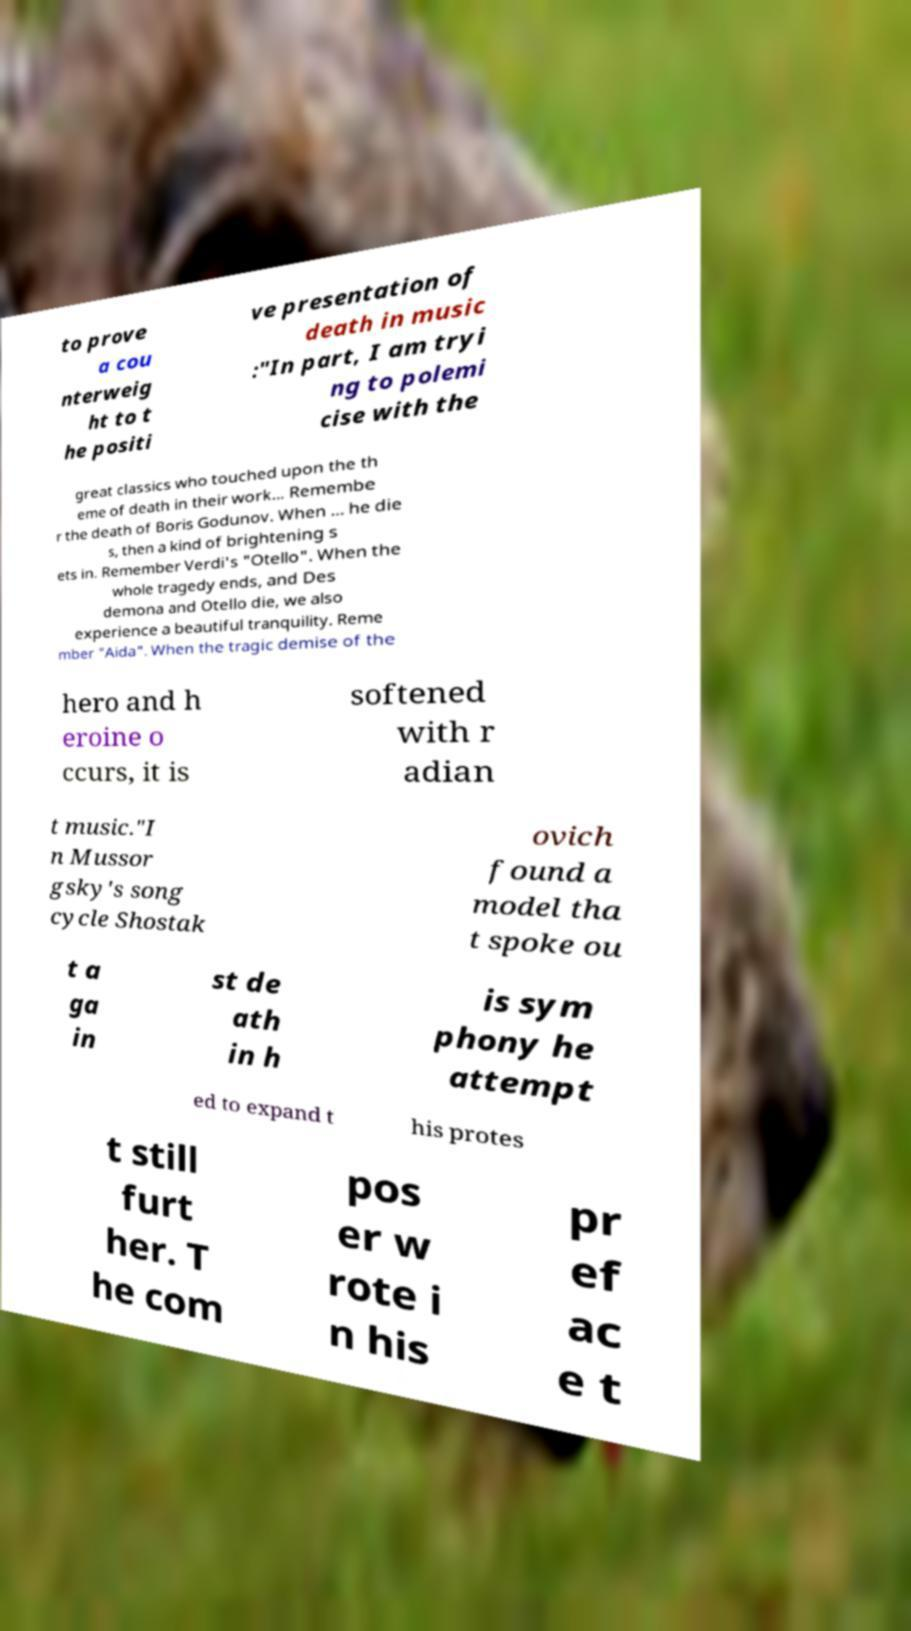Can you read and provide the text displayed in the image?This photo seems to have some interesting text. Can you extract and type it out for me? to prove a cou nterweig ht to t he positi ve presentation of death in music :"In part, I am tryi ng to polemi cise with the great classics who touched upon the th eme of death in their work... Remembe r the death of Boris Godunov. When ... he die s, then a kind of brightening s ets in. Remember Verdi's "Otello". When the whole tragedy ends, and Des demona and Otello die, we also experience a beautiful tranquility. Reme mber "Aida". When the tragic demise of the hero and h eroine o ccurs, it is softened with r adian t music."I n Mussor gsky's song cycle Shostak ovich found a model tha t spoke ou t a ga in st de ath in h is sym phony he attempt ed to expand t his protes t still furt her. T he com pos er w rote i n his pr ef ac e t 